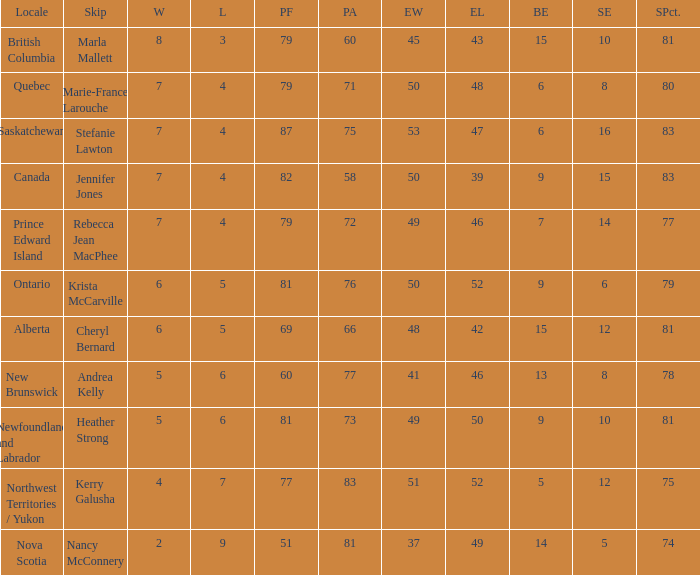Where was the shot pct 78? New Brunswick. 